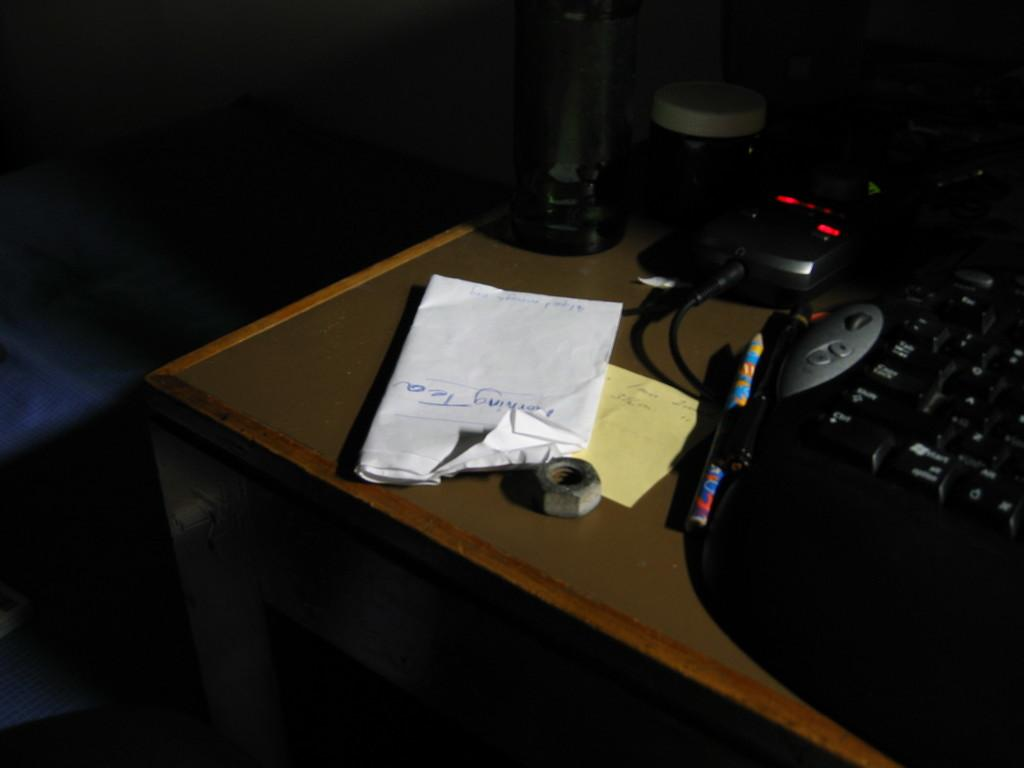<image>
Present a compact description of the photo's key features. A white piece of paper with "morning tea" sits on a table. 